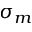<formula> <loc_0><loc_0><loc_500><loc_500>\sigma _ { m }</formula> 